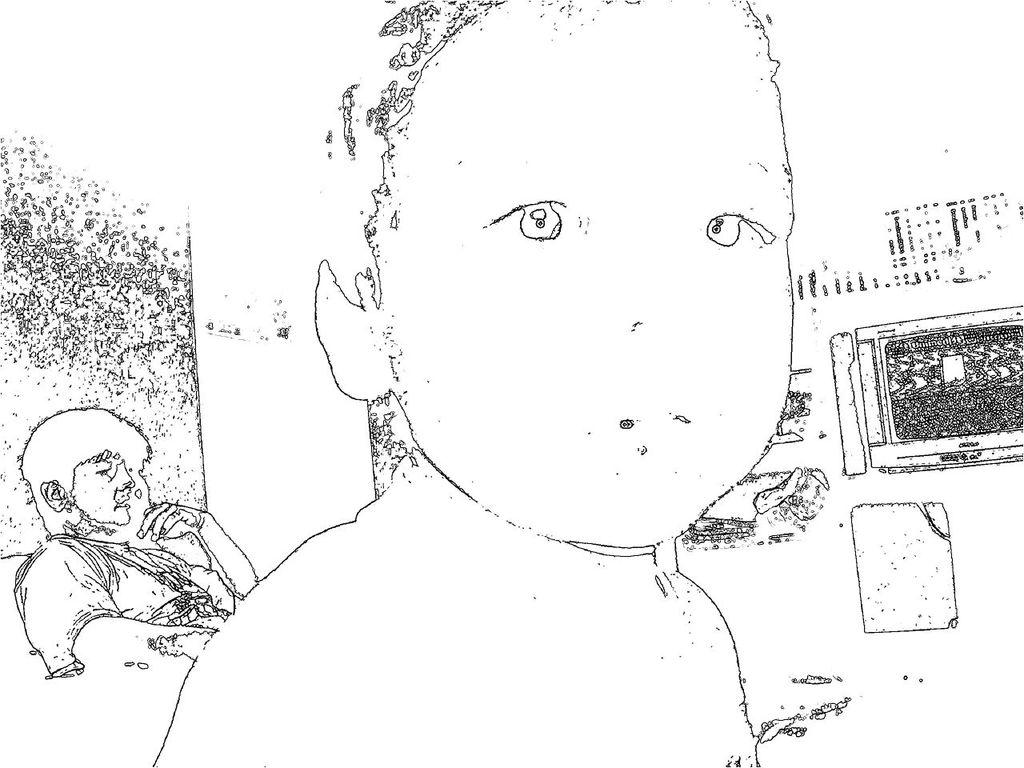How many people are in the image? There are two persons in the image. What can be said about the color of the sketch? The color of the sketch is black and white. What type of mass is being held by the person on the left in the image? There is no mass visible in the image, and it is not possible to determine what the person on the left might be holding. 